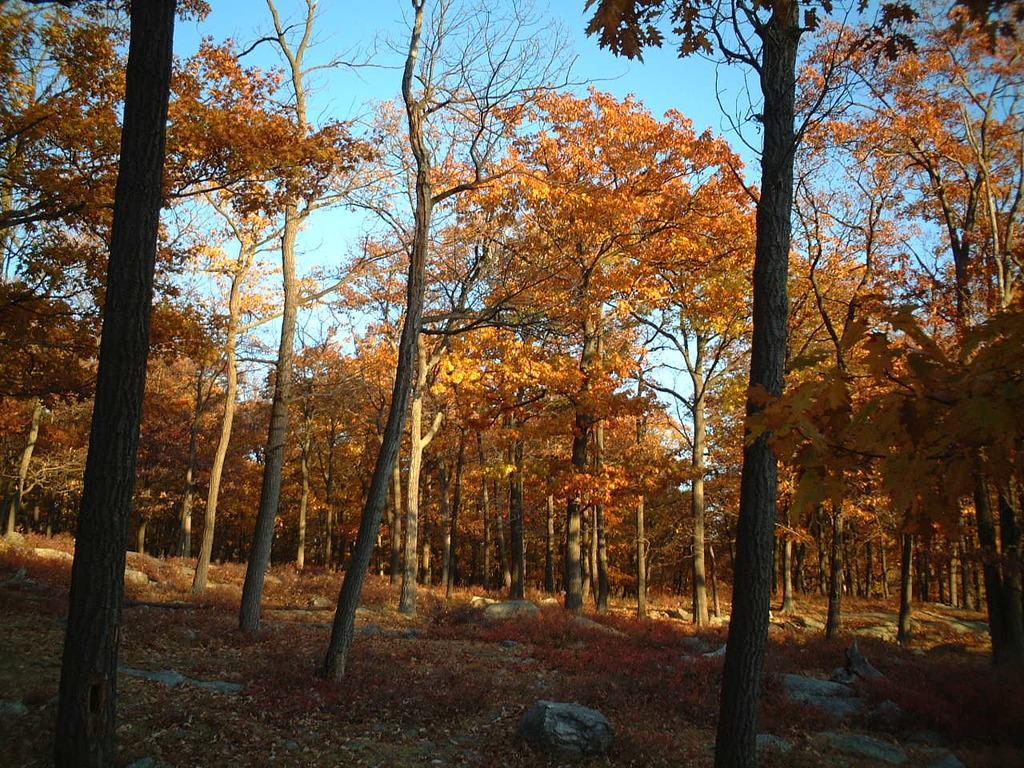In one or two sentences, can you explain what this image depicts? These are the trees with branches and leaves. I can see the rocks. I think this is the grass. 